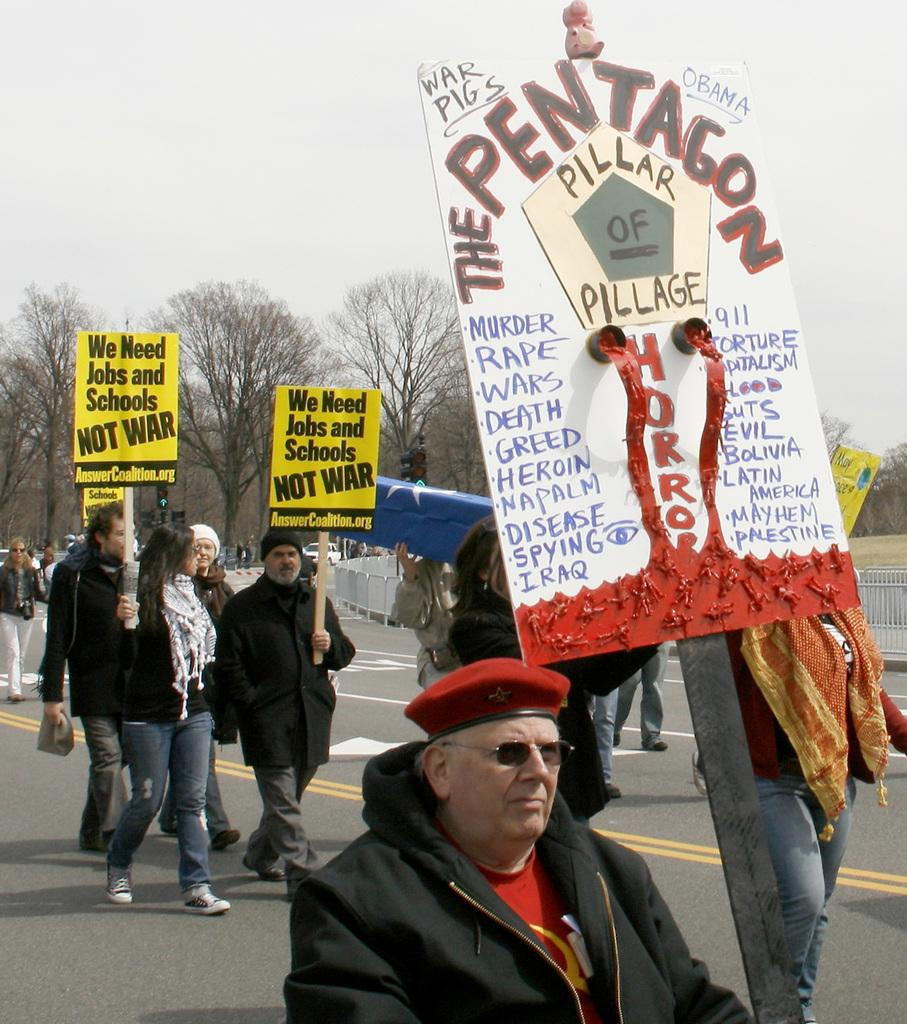What are the people on the road in the image doing? The people on the road in the image are holding placards. What can be seen in the background of the image? There is a fence, trees, and the sky visible in the background of the image. Can you tell me how many boys are flying in the image? There are no boys flying in the image. What type of creature is biting the people holding placards in the image? There are no creatures biting the people holding placards in the image. 